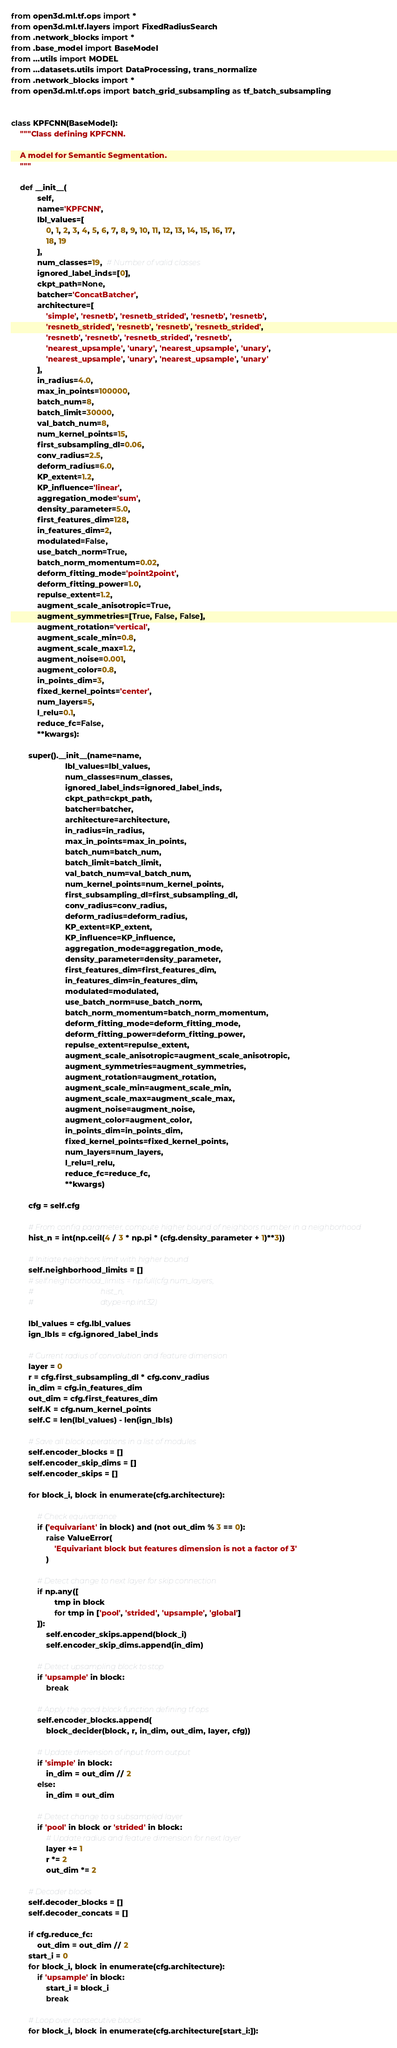<code> <loc_0><loc_0><loc_500><loc_500><_Python_>from open3d.ml.tf.ops import *
from open3d.ml.tf.layers import FixedRadiusSearch
from .network_blocks import *
from .base_model import BaseModel
from ...utils import MODEL
from ...datasets.utils import DataProcessing, trans_normalize
from .network_blocks import *
from open3d.ml.tf.ops import batch_grid_subsampling as tf_batch_subsampling


class KPFCNN(BaseModel):
    """Class defining KPFCNN.

    A model for Semantic Segmentation.
    """

    def __init__(
            self,
            name='KPFCNN',
            lbl_values=[
                0, 1, 2, 3, 4, 5, 6, 7, 8, 9, 10, 11, 12, 13, 14, 15, 16, 17,
                18, 19
            ],
            num_classes=19,  # Number of valid classes
            ignored_label_inds=[0],
            ckpt_path=None,
            batcher='ConcatBatcher',
            architecture=[
                'simple', 'resnetb', 'resnetb_strided', 'resnetb', 'resnetb',
                'resnetb_strided', 'resnetb', 'resnetb', 'resnetb_strided',
                'resnetb', 'resnetb', 'resnetb_strided', 'resnetb',
                'nearest_upsample', 'unary', 'nearest_upsample', 'unary',
                'nearest_upsample', 'unary', 'nearest_upsample', 'unary'
            ],
            in_radius=4.0,
            max_in_points=100000,
            batch_num=8,
            batch_limit=30000,
            val_batch_num=8,
            num_kernel_points=15,
            first_subsampling_dl=0.06,
            conv_radius=2.5,
            deform_radius=6.0,
            KP_extent=1.2,
            KP_influence='linear',
            aggregation_mode='sum',
            density_parameter=5.0,
            first_features_dim=128,
            in_features_dim=2,
            modulated=False,
            use_batch_norm=True,
            batch_norm_momentum=0.02,
            deform_fitting_mode='point2point',
            deform_fitting_power=1.0,
            repulse_extent=1.2,
            augment_scale_anisotropic=True,
            augment_symmetries=[True, False, False],
            augment_rotation='vertical',
            augment_scale_min=0.8,
            augment_scale_max=1.2,
            augment_noise=0.001,
            augment_color=0.8,
            in_points_dim=3,
            fixed_kernel_points='center',
            num_layers=5,
            l_relu=0.1,
            reduce_fc=False,
            **kwargs):

        super().__init__(name=name,
                         lbl_values=lbl_values,
                         num_classes=num_classes,
                         ignored_label_inds=ignored_label_inds,
                         ckpt_path=ckpt_path,
                         batcher=batcher,
                         architecture=architecture,
                         in_radius=in_radius,
                         max_in_points=max_in_points,
                         batch_num=batch_num,
                         batch_limit=batch_limit,
                         val_batch_num=val_batch_num,
                         num_kernel_points=num_kernel_points,
                         first_subsampling_dl=first_subsampling_dl,
                         conv_radius=conv_radius,
                         deform_radius=deform_radius,
                         KP_extent=KP_extent,
                         KP_influence=KP_influence,
                         aggregation_mode=aggregation_mode,
                         density_parameter=density_parameter,
                         first_features_dim=first_features_dim,
                         in_features_dim=in_features_dim,
                         modulated=modulated,
                         use_batch_norm=use_batch_norm,
                         batch_norm_momentum=batch_norm_momentum,
                         deform_fitting_mode=deform_fitting_mode,
                         deform_fitting_power=deform_fitting_power,
                         repulse_extent=repulse_extent,
                         augment_scale_anisotropic=augment_scale_anisotropic,
                         augment_symmetries=augment_symmetries,
                         augment_rotation=augment_rotation,
                         augment_scale_min=augment_scale_min,
                         augment_scale_max=augment_scale_max,
                         augment_noise=augment_noise,
                         augment_color=augment_color,
                         in_points_dim=in_points_dim,
                         fixed_kernel_points=fixed_kernel_points,
                         num_layers=num_layers,
                         l_relu=l_relu,
                         reduce_fc=reduce_fc,
                         **kwargs)

        cfg = self.cfg

        # From config parameter, compute higher bound of neighbors number in a neighborhood
        hist_n = int(np.ceil(4 / 3 * np.pi * (cfg.density_parameter + 1)**3))

        # Initiate neighbors limit with higher bound
        self.neighborhood_limits = []
        # self.neighborhood_limits = np.full(cfg.num_layers,
        #                                    hist_n,
        #                                    dtype=np.int32)

        lbl_values = cfg.lbl_values
        ign_lbls = cfg.ignored_label_inds

        # Current radius of convolution and feature dimension
        layer = 0
        r = cfg.first_subsampling_dl * cfg.conv_radius
        in_dim = cfg.in_features_dim
        out_dim = cfg.first_features_dim
        self.K = cfg.num_kernel_points
        self.C = len(lbl_values) - len(ign_lbls)

        # Save all block operations in a list of modules
        self.encoder_blocks = []
        self.encoder_skip_dims = []
        self.encoder_skips = []

        for block_i, block in enumerate(cfg.architecture):

            # Check equivariance
            if ('equivariant' in block) and (not out_dim % 3 == 0):
                raise ValueError(
                    'Equivariant block but features dimension is not a factor of 3'
                )

            # Detect change to next layer for skip connection
            if np.any([
                    tmp in block
                    for tmp in ['pool', 'strided', 'upsample', 'global']
            ]):
                self.encoder_skips.append(block_i)
                self.encoder_skip_dims.append(in_dim)

            # Detect upsampling block to stop
            if 'upsample' in block:
                break

            # Apply the good block function defining tf ops
            self.encoder_blocks.append(
                block_decider(block, r, in_dim, out_dim, layer, cfg))

            # Update dimension of input from output
            if 'simple' in block:
                in_dim = out_dim // 2
            else:
                in_dim = out_dim

            # Detect change to a subsampled layer
            if 'pool' in block or 'strided' in block:
                # Update radius and feature dimension for next layer
                layer += 1
                r *= 2
                out_dim *= 2

        # Decoder blocks
        self.decoder_blocks = []
        self.decoder_concats = []

        if cfg.reduce_fc:
            out_dim = out_dim // 2
        start_i = 0
        for block_i, block in enumerate(cfg.architecture):
            if 'upsample' in block:
                start_i = block_i
                break

        # Loop over consecutive blocks
        for block_i, block in enumerate(cfg.architecture[start_i:]):
</code> 